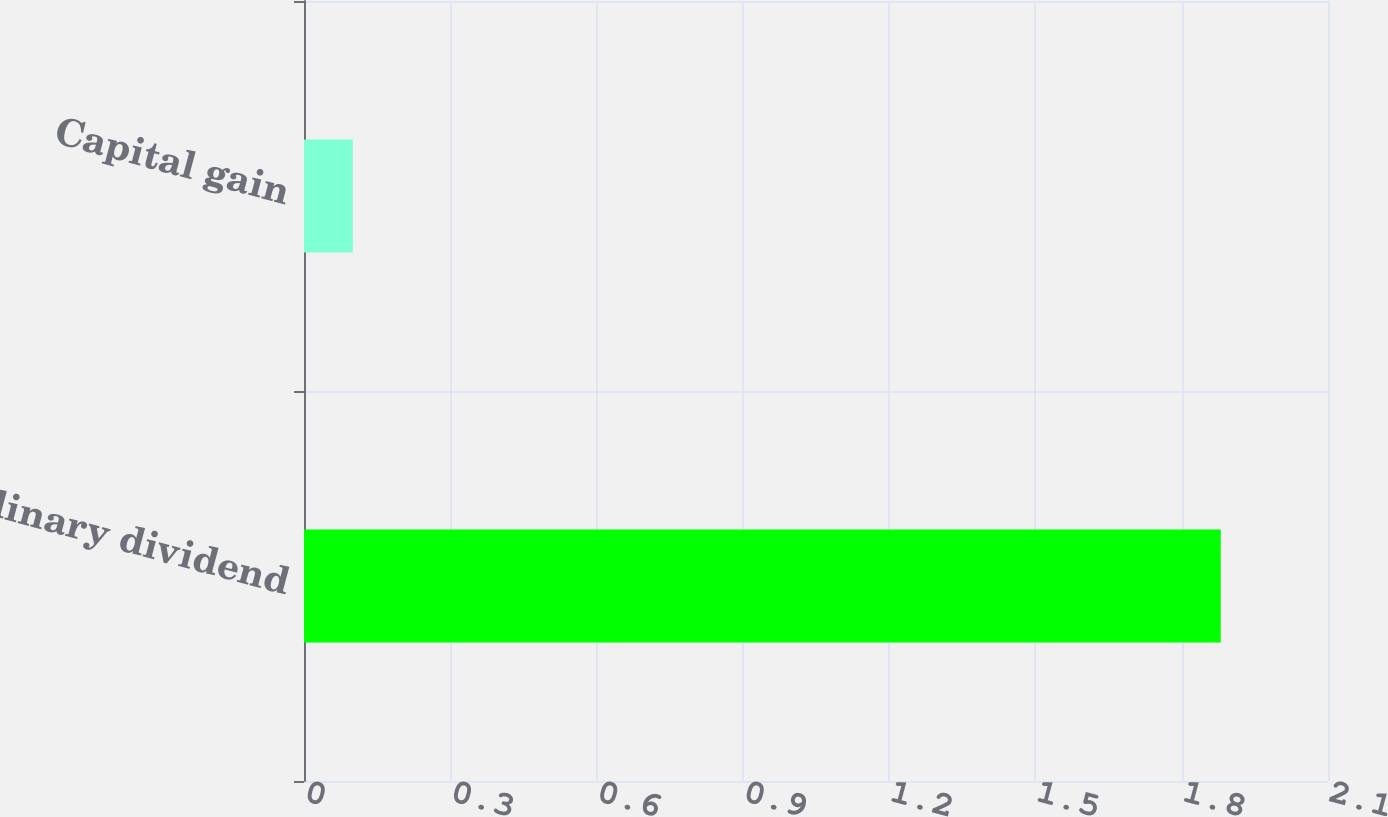<chart> <loc_0><loc_0><loc_500><loc_500><bar_chart><fcel>Ordinary dividend<fcel>Capital gain<nl><fcel>1.88<fcel>0.1<nl></chart> 